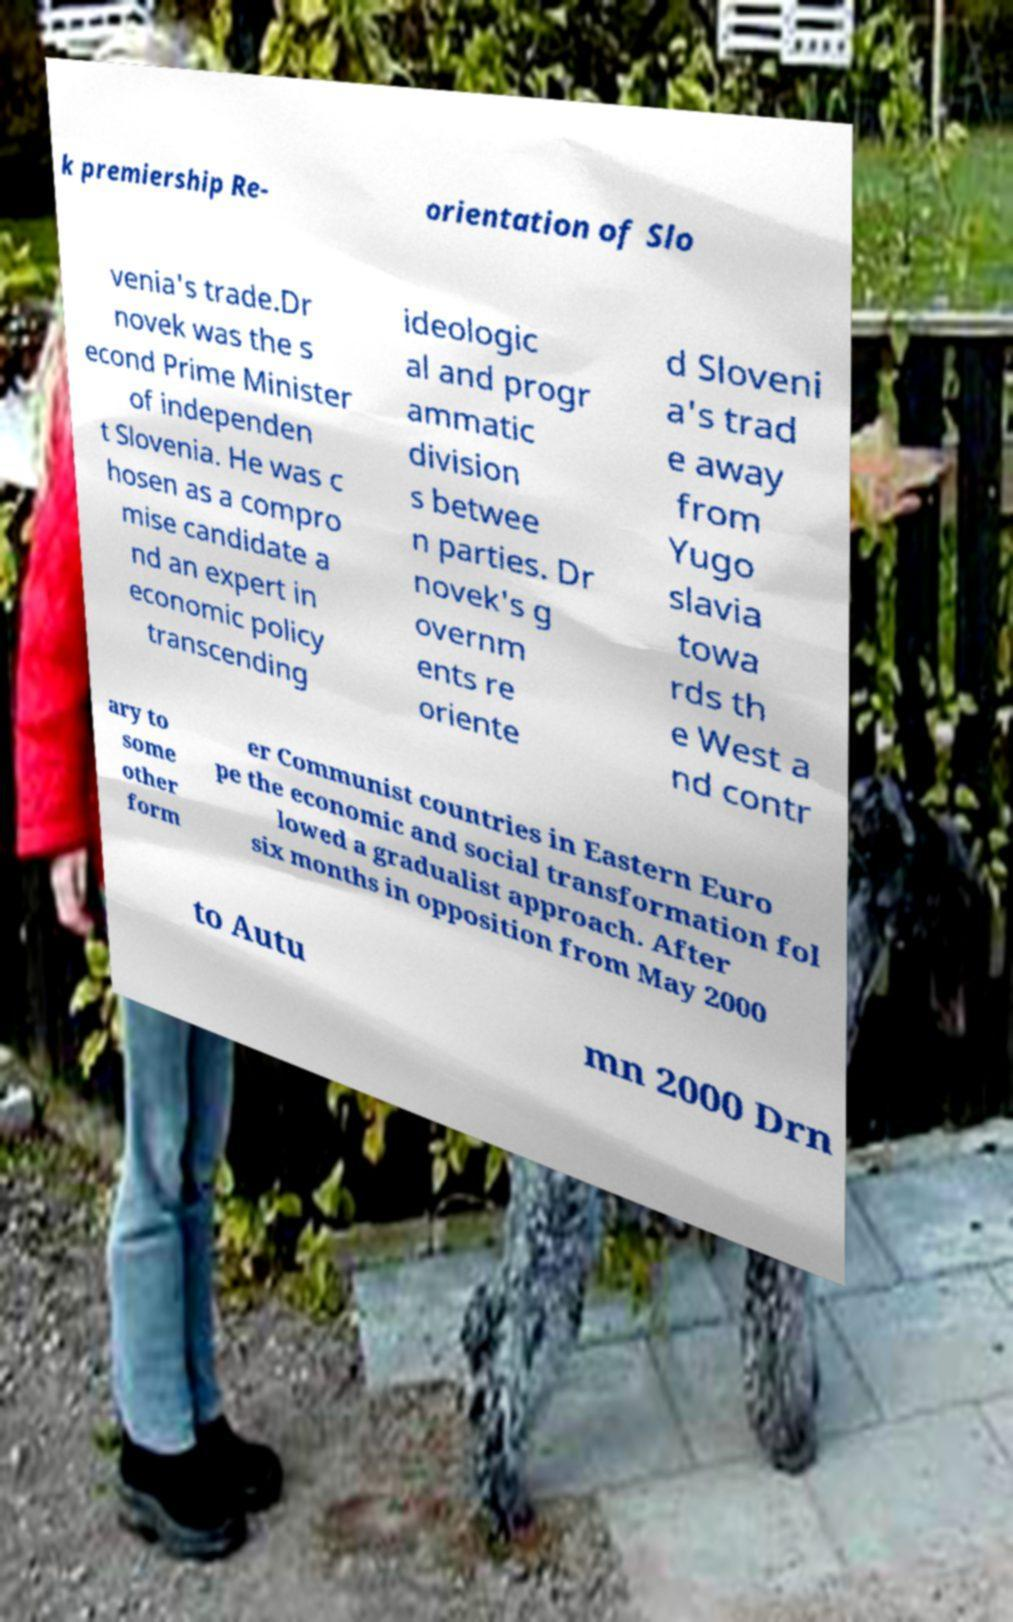Please identify and transcribe the text found in this image. k premiership Re- orientation of Slo venia's trade.Dr novek was the s econd Prime Minister of independen t Slovenia. He was c hosen as a compro mise candidate a nd an expert in economic policy transcending ideologic al and progr ammatic division s betwee n parties. Dr novek's g overnm ents re oriente d Sloveni a's trad e away from Yugo slavia towa rds th e West a nd contr ary to some other form er Communist countries in Eastern Euro pe the economic and social transformation fol lowed a gradualist approach. After six months in opposition from May 2000 to Autu mn 2000 Drn 